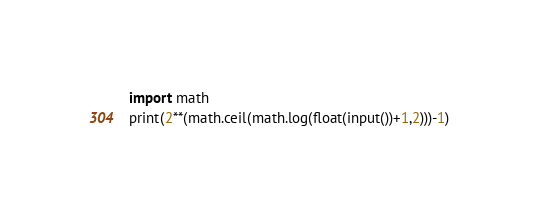Convert code to text. <code><loc_0><loc_0><loc_500><loc_500><_Python_>import math
print(2**(math.ceil(math.log(float(input())+1,2)))-1)</code> 